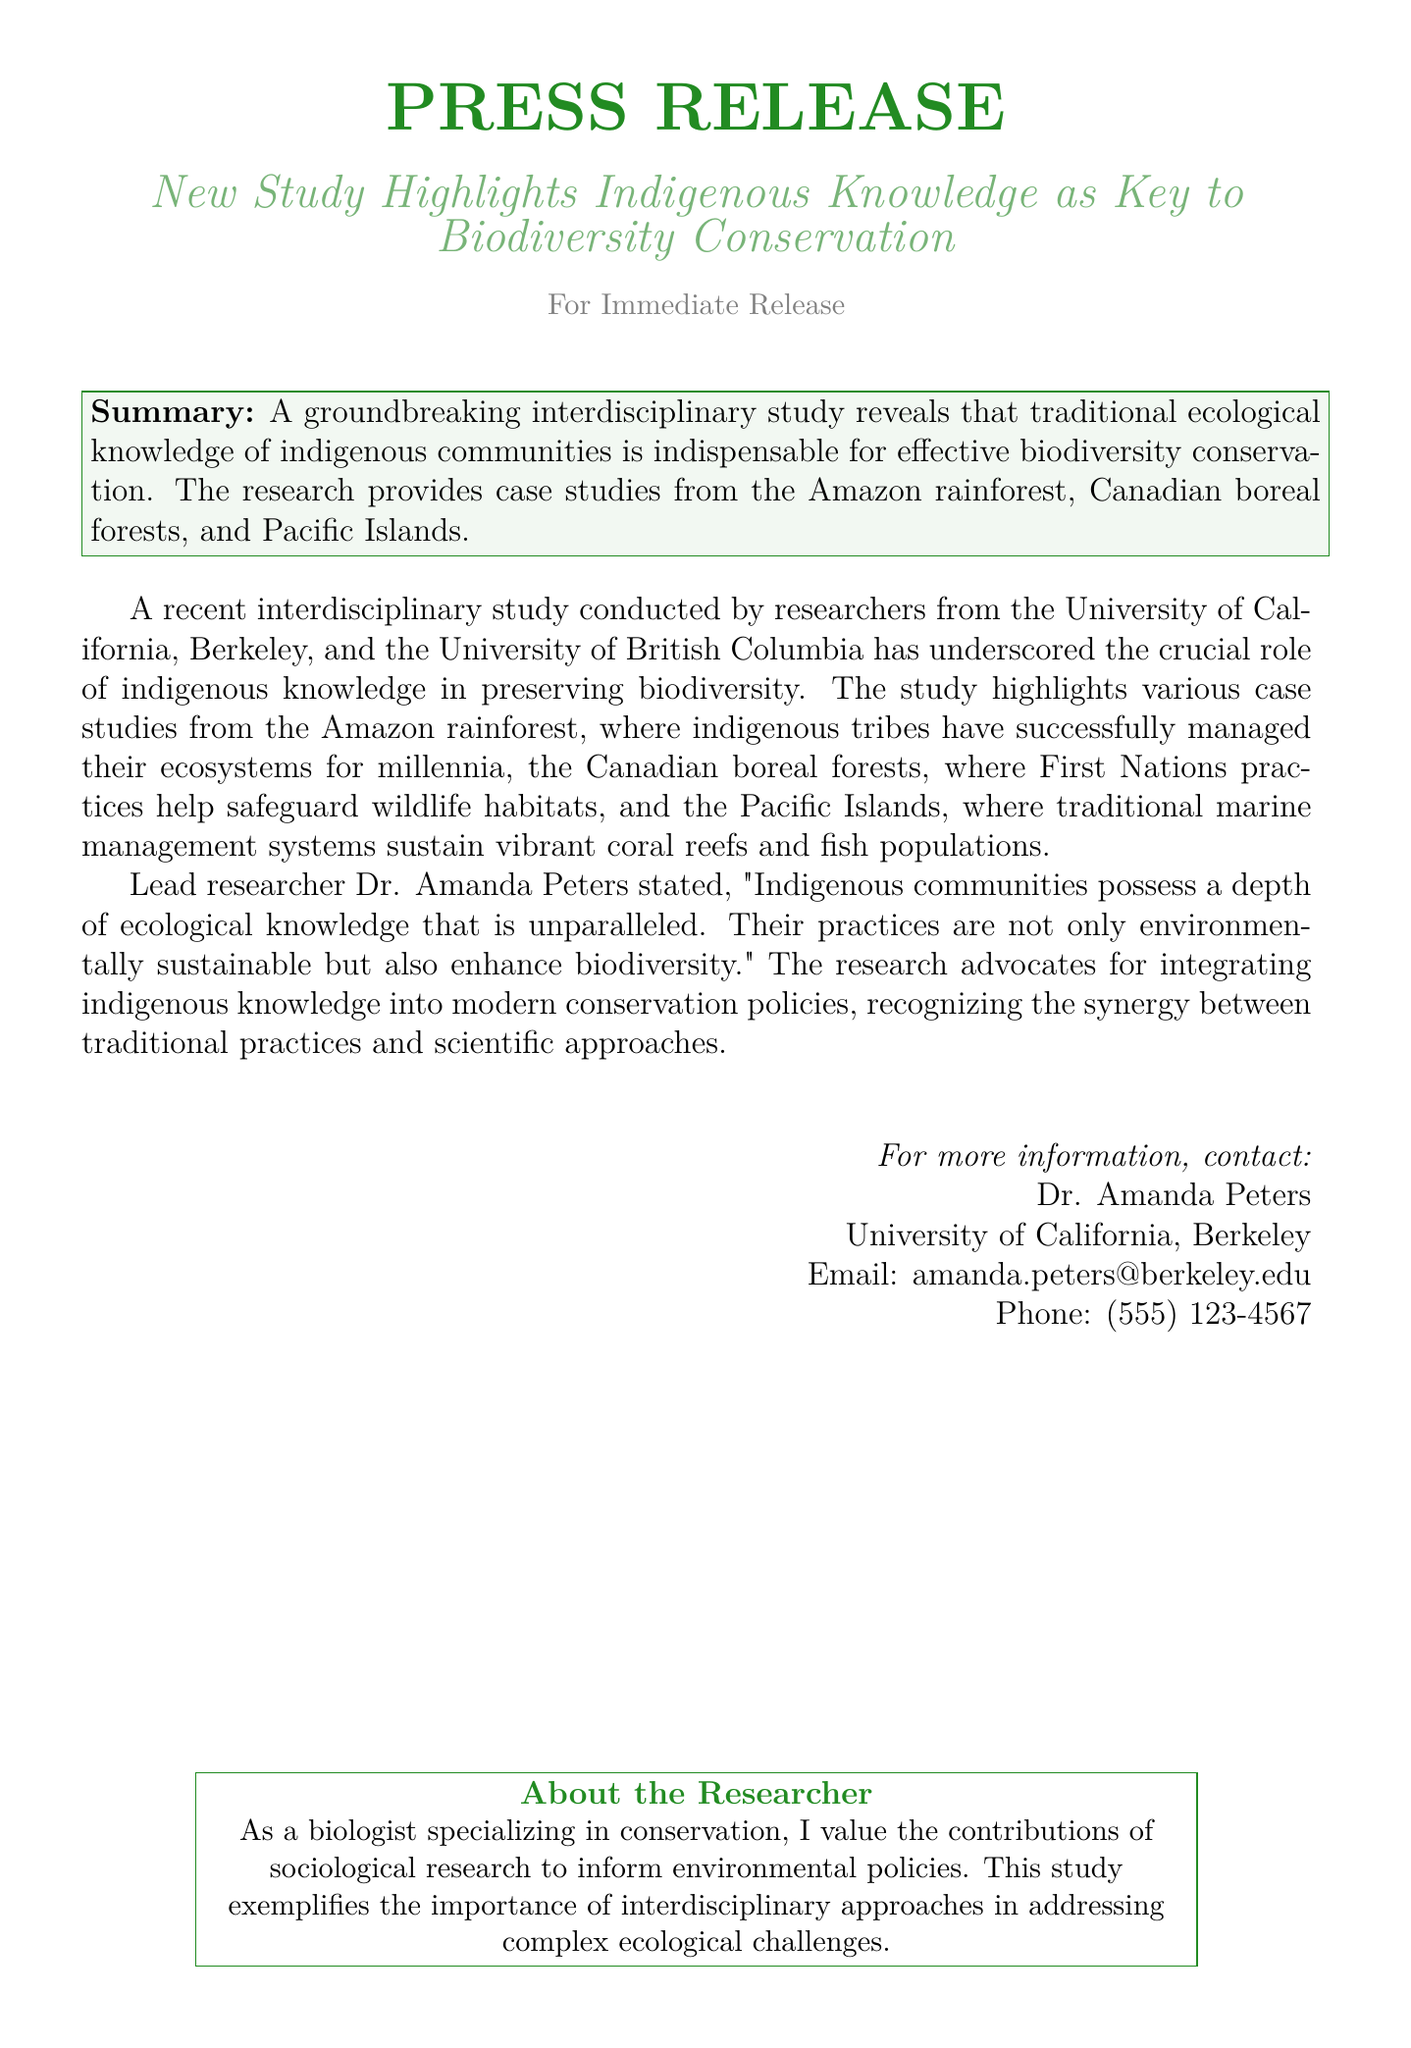What is the title of the study? The title of the study is mentioned in the press release as an important aspect of the research findings.
Answer: New Study Highlights Indigenous Knowledge as Key to Biodiversity Conservation Who stated that indigenous communities possess unparalleled ecological knowledge? The press release provides the name of the lead researcher who made this statement, reflecting the study's findings.
Answer: Dr. Amanda Peters What are some of the regions highlighted in the case studies? The press release lists these regions to showcase the application of indigenous knowledge in biodiversity conservation.
Answer: Amazon rainforest, Canadian boreal forests, Pacific Islands What is emphasized as essential for effective biodiversity conservation? The press release notes the significance of this aspect in the context of the study conducted.
Answer: Traditional ecological knowledge Which university is Dr. Amanda Peters affiliated with? The press release includes information about the researchers involved in the study, specifically mentioning the affiliation of Dr. Amanda Peters.
Answer: University of California, Berkeley What type of approach does the study advocate for in conservation policies? The document describes the recommended strategy that combines two important elements for better outcomes in conservation efforts.
Answer: Interdisciplinary approaches What is described as being improved through the integration of indigenous practices? The press release mentions the benefits of incorporating certain knowledge systems, highlighting their effectiveness in conservation.
Answer: Biodiversity How can one contact Dr. Amanda Peters for more information? The contact information provided in the press release gives details on how to reach the lead researcher, fulfilling a common inquiry about media contacts.
Answer: amanda.peters@berkeley.edu 